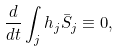<formula> <loc_0><loc_0><loc_500><loc_500>\frac { d } { d t } \int _ { j } h _ { j } \bar { S } _ { j } \equiv 0 ,</formula> 